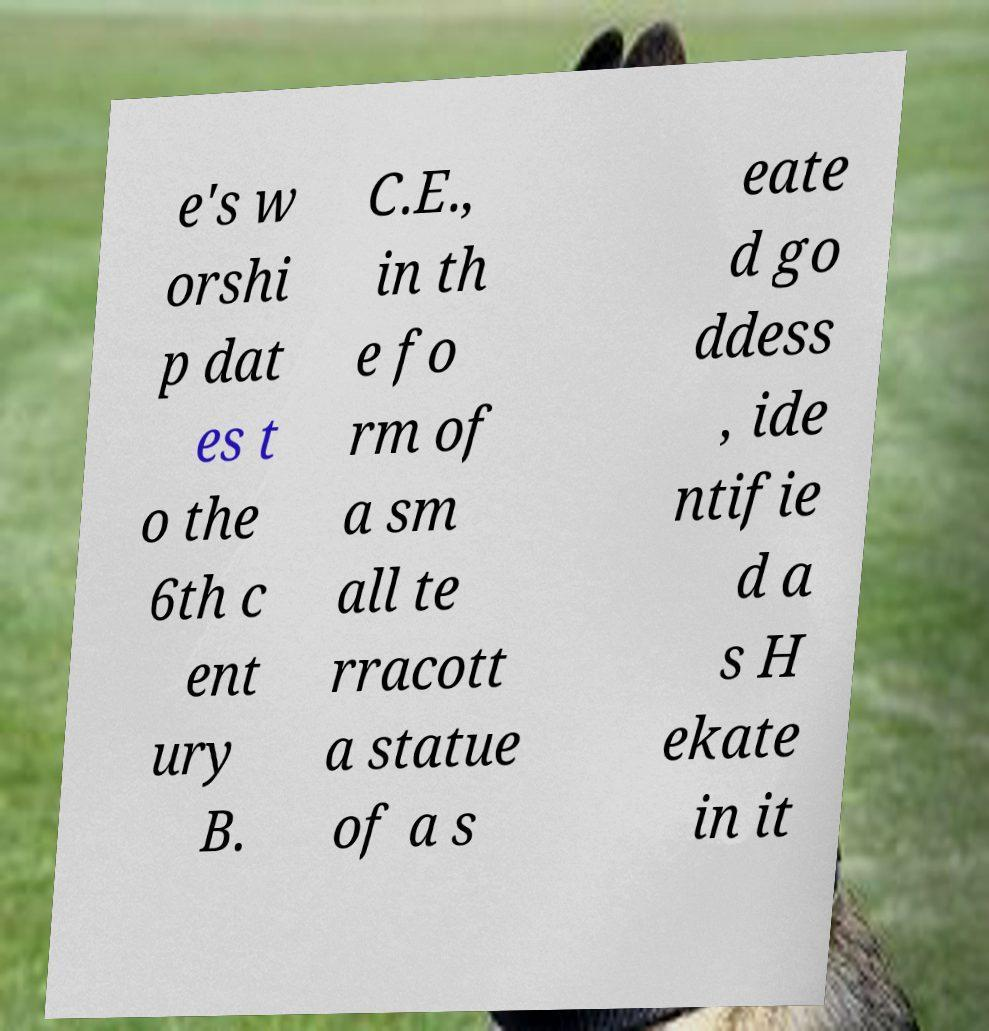I need the written content from this picture converted into text. Can you do that? e's w orshi p dat es t o the 6th c ent ury B. C.E., in th e fo rm of a sm all te rracott a statue of a s eate d go ddess , ide ntifie d a s H ekate in it 